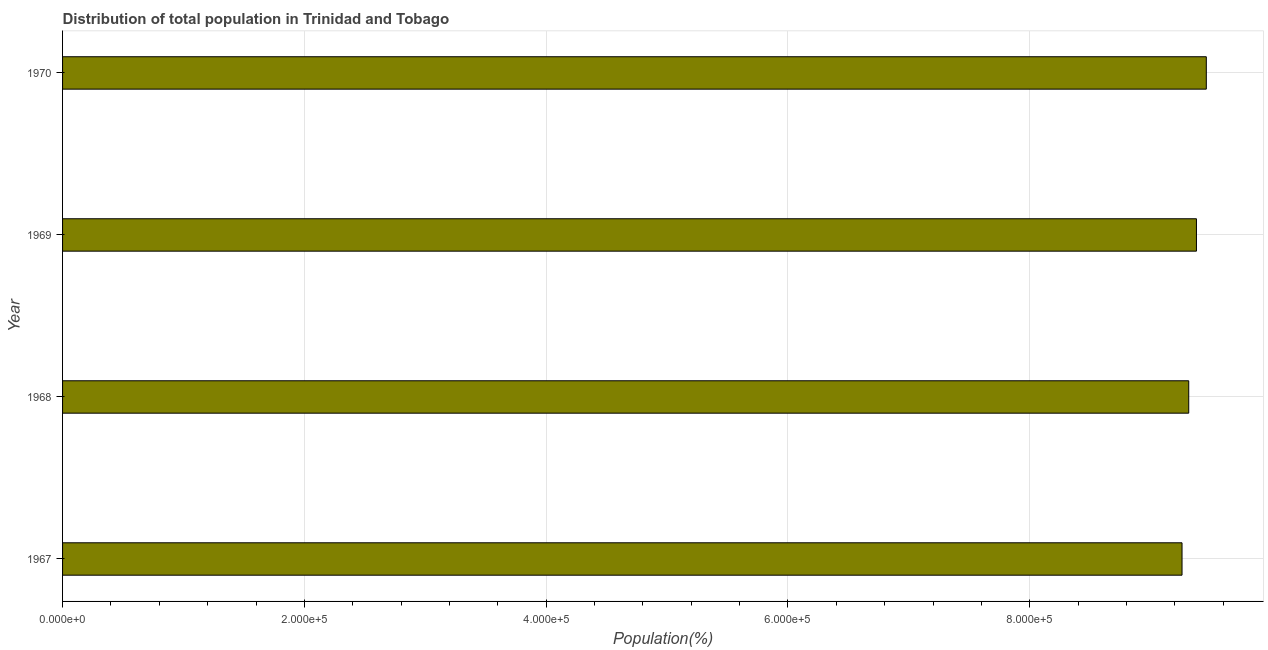Does the graph contain any zero values?
Offer a terse response. No. Does the graph contain grids?
Your response must be concise. Yes. What is the title of the graph?
Give a very brief answer. Distribution of total population in Trinidad and Tobago . What is the label or title of the X-axis?
Your response must be concise. Population(%). What is the label or title of the Y-axis?
Provide a succinct answer. Year. What is the population in 1969?
Your answer should be very brief. 9.38e+05. Across all years, what is the maximum population?
Your answer should be compact. 9.46e+05. Across all years, what is the minimum population?
Make the answer very short. 9.26e+05. In which year was the population minimum?
Provide a short and direct response. 1967. What is the sum of the population?
Offer a very short reply. 3.74e+06. What is the difference between the population in 1969 and 1970?
Provide a short and direct response. -8150. What is the average population per year?
Give a very brief answer. 9.35e+05. What is the median population?
Provide a succinct answer. 9.35e+05. In how many years, is the population greater than 400000 %?
Your response must be concise. 4. Do a majority of the years between 1967 and 1969 (inclusive) have population greater than 40000 %?
Give a very brief answer. Yes. What is the ratio of the population in 1967 to that in 1968?
Your response must be concise. 0.99. Is the difference between the population in 1969 and 1970 greater than the difference between any two years?
Ensure brevity in your answer.  No. What is the difference between the highest and the second highest population?
Make the answer very short. 8150. What is the difference between the highest and the lowest population?
Keep it short and to the point. 2.01e+04. In how many years, is the population greater than the average population taken over all years?
Provide a succinct answer. 2. Are all the bars in the graph horizontal?
Your response must be concise. Yes. Are the values on the major ticks of X-axis written in scientific E-notation?
Offer a terse response. Yes. What is the Population(%) of 1967?
Your response must be concise. 9.26e+05. What is the Population(%) in 1968?
Give a very brief answer. 9.31e+05. What is the Population(%) in 1969?
Your answer should be very brief. 9.38e+05. What is the Population(%) in 1970?
Your answer should be very brief. 9.46e+05. What is the difference between the Population(%) in 1967 and 1968?
Provide a succinct answer. -5548. What is the difference between the Population(%) in 1967 and 1969?
Your answer should be very brief. -1.19e+04. What is the difference between the Population(%) in 1967 and 1970?
Your answer should be very brief. -2.01e+04. What is the difference between the Population(%) in 1968 and 1969?
Provide a short and direct response. -6380. What is the difference between the Population(%) in 1968 and 1970?
Provide a short and direct response. -1.45e+04. What is the difference between the Population(%) in 1969 and 1970?
Give a very brief answer. -8150. What is the ratio of the Population(%) in 1967 to that in 1969?
Your answer should be compact. 0.99. What is the ratio of the Population(%) in 1968 to that in 1970?
Your response must be concise. 0.98. 